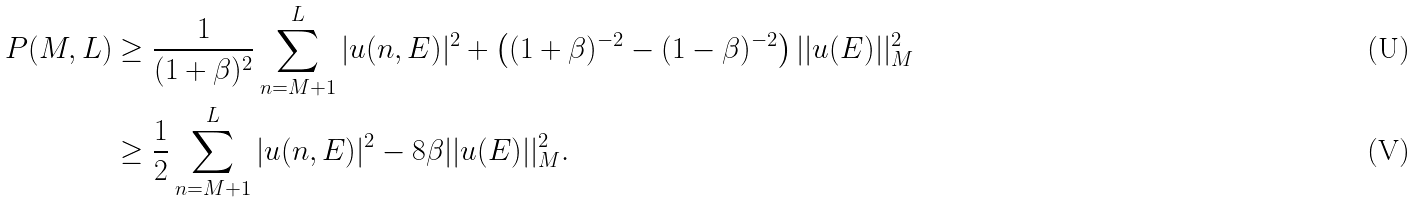Convert formula to latex. <formula><loc_0><loc_0><loc_500><loc_500>P ( M , L ) & \geq \frac { 1 } { ( 1 + \beta ) ^ { 2 } } \sum _ { n = M + 1 } ^ { L } | u ( n , E ) | ^ { 2 } + \left ( ( 1 + \beta ) ^ { - 2 } - ( 1 - \beta ) ^ { - 2 } \right ) | | u ( E ) | | _ { M } ^ { 2 } \\ & \geq \frac { 1 } { 2 } \sum _ { n = M + 1 } ^ { L } | u ( n , E ) | ^ { 2 } - 8 \beta | | u ( E ) | | _ { M } ^ { 2 } .</formula> 